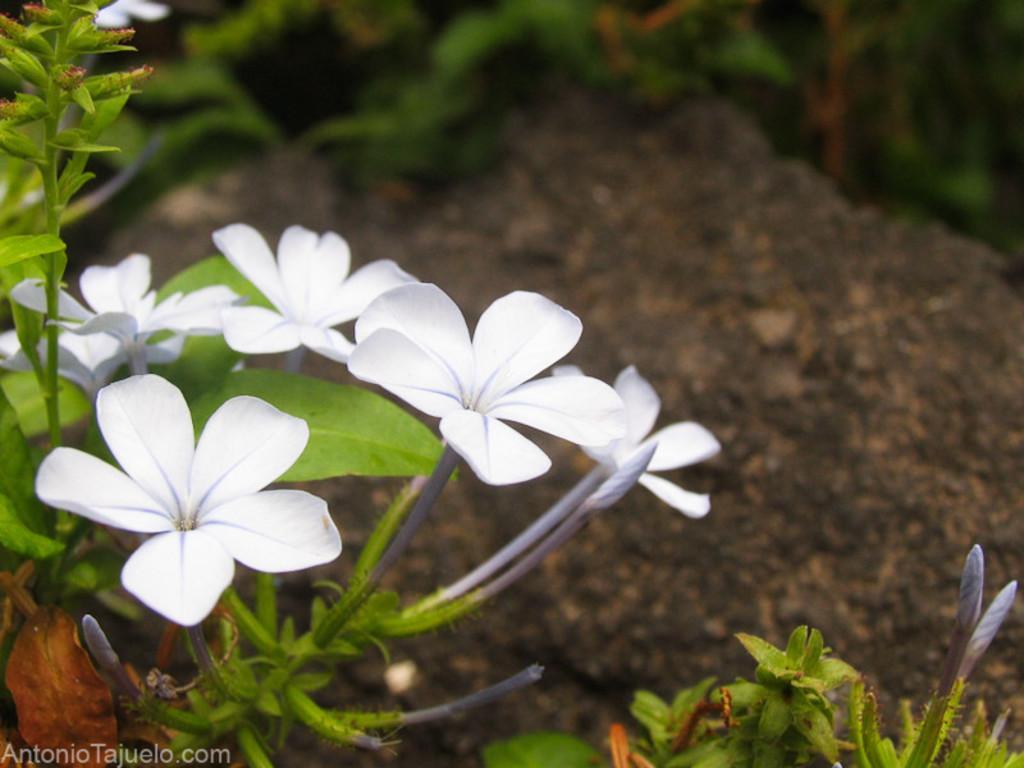Could you give a brief overview of what you see in this image? In this picture I can see the plants in front, on which there are flowers which are of white color and I see few buds. It is blurred in the background and I see the watermark on the bottom left corner of this image. 